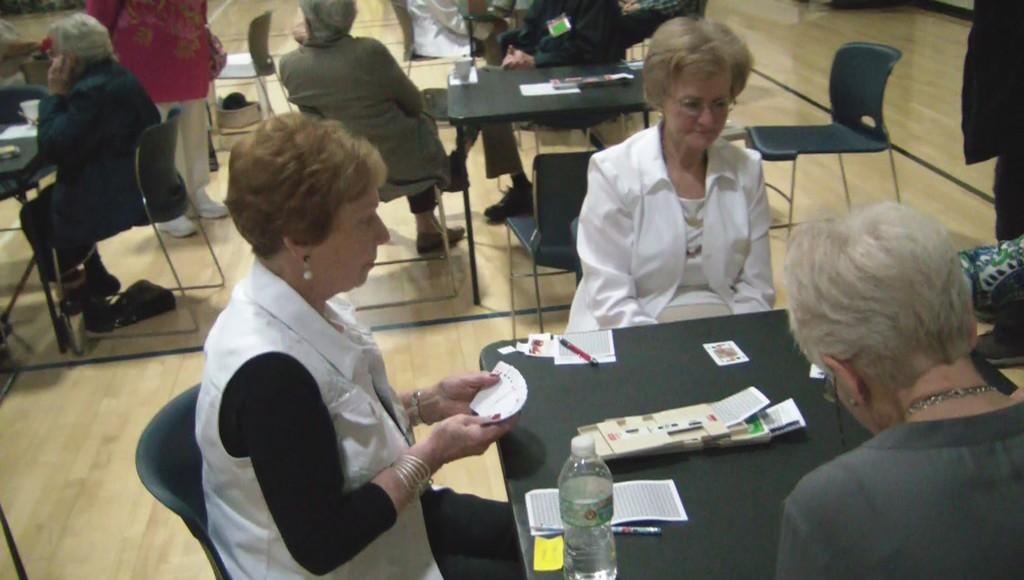What type of furniture is present in the image? There are chairs and tables in the image. What objects can be seen on the tables? There are bottles, cups, papers, and cards on the tables. What stationery items are present on the tables? There are pens on the tables. What is the position of the people in the image? There are people sitting and standing near the tables. What type of treatment is being administered to the person wearing a skirt in the image? There is no person wearing a skirt in the image, and no treatment is being administered. How does the person wearing a skirt turn around in the image? There is no person wearing a skirt in the image, so they cannot turn around. 